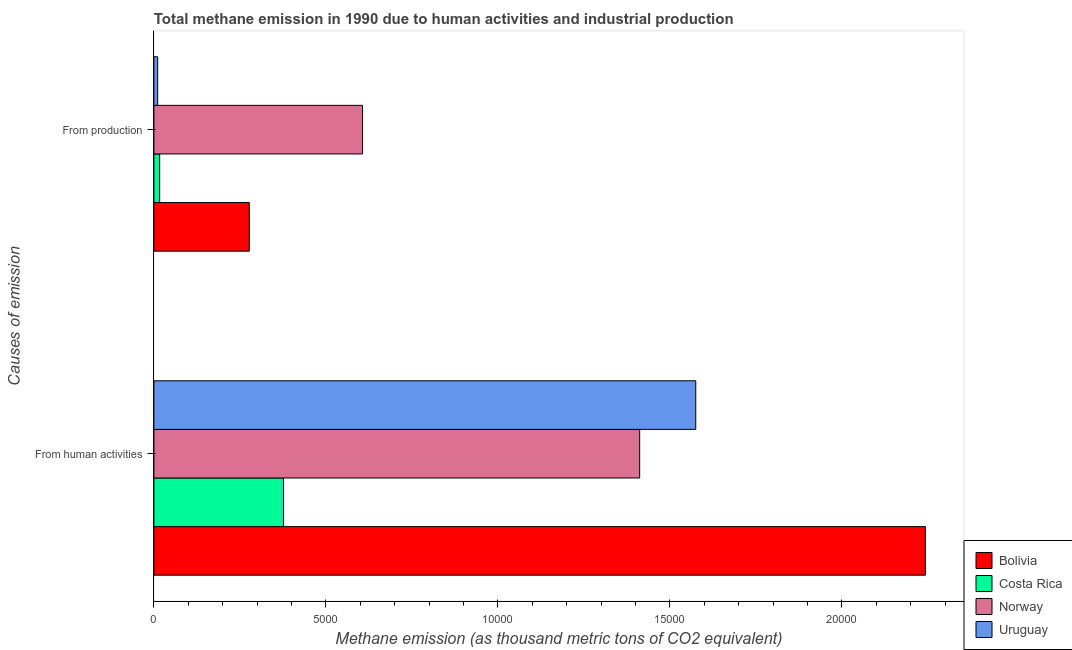How many groups of bars are there?
Your answer should be very brief. 2. How many bars are there on the 1st tick from the top?
Provide a short and direct response. 4. How many bars are there on the 1st tick from the bottom?
Your answer should be compact. 4. What is the label of the 2nd group of bars from the top?
Your answer should be compact. From human activities. What is the amount of emissions generated from industries in Bolivia?
Offer a very short reply. 2773.8. Across all countries, what is the maximum amount of emissions generated from industries?
Provide a short and direct response. 6065.9. Across all countries, what is the minimum amount of emissions from human activities?
Offer a terse response. 3768.5. In which country was the amount of emissions generated from industries maximum?
Offer a terse response. Norway. In which country was the amount of emissions from human activities minimum?
Ensure brevity in your answer.  Costa Rica. What is the total amount of emissions from human activities in the graph?
Your response must be concise. 5.61e+04. What is the difference between the amount of emissions generated from industries in Norway and that in Costa Rica?
Your response must be concise. 5897.7. What is the difference between the amount of emissions generated from industries in Uruguay and the amount of emissions from human activities in Costa Rica?
Your answer should be very brief. -3658.2. What is the average amount of emissions generated from industries per country?
Offer a terse response. 2279.55. What is the difference between the amount of emissions generated from industries and amount of emissions from human activities in Norway?
Offer a very short reply. -8056. In how many countries, is the amount of emissions from human activities greater than 6000 thousand metric tons?
Ensure brevity in your answer.  3. What is the ratio of the amount of emissions from human activities in Costa Rica to that in Norway?
Offer a terse response. 0.27. Is the amount of emissions generated from industries in Norway less than that in Bolivia?
Your answer should be very brief. No. What does the 1st bar from the top in From human activities represents?
Provide a short and direct response. Uruguay. What does the 1st bar from the bottom in From human activities represents?
Ensure brevity in your answer.  Bolivia. Does the graph contain any zero values?
Provide a short and direct response. No. How many legend labels are there?
Give a very brief answer. 4. What is the title of the graph?
Offer a terse response. Total methane emission in 1990 due to human activities and industrial production. Does "Macedonia" appear as one of the legend labels in the graph?
Give a very brief answer. No. What is the label or title of the X-axis?
Offer a very short reply. Methane emission (as thousand metric tons of CO2 equivalent). What is the label or title of the Y-axis?
Your answer should be compact. Causes of emission. What is the Methane emission (as thousand metric tons of CO2 equivalent) of Bolivia in From human activities?
Offer a very short reply. 2.24e+04. What is the Methane emission (as thousand metric tons of CO2 equivalent) in Costa Rica in From human activities?
Give a very brief answer. 3768.5. What is the Methane emission (as thousand metric tons of CO2 equivalent) in Norway in From human activities?
Your response must be concise. 1.41e+04. What is the Methane emission (as thousand metric tons of CO2 equivalent) in Uruguay in From human activities?
Your answer should be very brief. 1.58e+04. What is the Methane emission (as thousand metric tons of CO2 equivalent) of Bolivia in From production?
Your answer should be very brief. 2773.8. What is the Methane emission (as thousand metric tons of CO2 equivalent) in Costa Rica in From production?
Keep it short and to the point. 168.2. What is the Methane emission (as thousand metric tons of CO2 equivalent) of Norway in From production?
Provide a short and direct response. 6065.9. What is the Methane emission (as thousand metric tons of CO2 equivalent) of Uruguay in From production?
Offer a very short reply. 110.3. Across all Causes of emission, what is the maximum Methane emission (as thousand metric tons of CO2 equivalent) in Bolivia?
Give a very brief answer. 2.24e+04. Across all Causes of emission, what is the maximum Methane emission (as thousand metric tons of CO2 equivalent) in Costa Rica?
Give a very brief answer. 3768.5. Across all Causes of emission, what is the maximum Methane emission (as thousand metric tons of CO2 equivalent) in Norway?
Your answer should be compact. 1.41e+04. Across all Causes of emission, what is the maximum Methane emission (as thousand metric tons of CO2 equivalent) in Uruguay?
Ensure brevity in your answer.  1.58e+04. Across all Causes of emission, what is the minimum Methane emission (as thousand metric tons of CO2 equivalent) in Bolivia?
Offer a very short reply. 2773.8. Across all Causes of emission, what is the minimum Methane emission (as thousand metric tons of CO2 equivalent) in Costa Rica?
Offer a terse response. 168.2. Across all Causes of emission, what is the minimum Methane emission (as thousand metric tons of CO2 equivalent) in Norway?
Offer a very short reply. 6065.9. Across all Causes of emission, what is the minimum Methane emission (as thousand metric tons of CO2 equivalent) of Uruguay?
Offer a very short reply. 110.3. What is the total Methane emission (as thousand metric tons of CO2 equivalent) of Bolivia in the graph?
Your answer should be very brief. 2.52e+04. What is the total Methane emission (as thousand metric tons of CO2 equivalent) of Costa Rica in the graph?
Your answer should be compact. 3936.7. What is the total Methane emission (as thousand metric tons of CO2 equivalent) in Norway in the graph?
Your answer should be very brief. 2.02e+04. What is the total Methane emission (as thousand metric tons of CO2 equivalent) in Uruguay in the graph?
Your answer should be very brief. 1.59e+04. What is the difference between the Methane emission (as thousand metric tons of CO2 equivalent) of Bolivia in From human activities and that in From production?
Give a very brief answer. 1.97e+04. What is the difference between the Methane emission (as thousand metric tons of CO2 equivalent) in Costa Rica in From human activities and that in From production?
Give a very brief answer. 3600.3. What is the difference between the Methane emission (as thousand metric tons of CO2 equivalent) in Norway in From human activities and that in From production?
Make the answer very short. 8056. What is the difference between the Methane emission (as thousand metric tons of CO2 equivalent) of Uruguay in From human activities and that in From production?
Your response must be concise. 1.56e+04. What is the difference between the Methane emission (as thousand metric tons of CO2 equivalent) in Bolivia in From human activities and the Methane emission (as thousand metric tons of CO2 equivalent) in Costa Rica in From production?
Make the answer very short. 2.23e+04. What is the difference between the Methane emission (as thousand metric tons of CO2 equivalent) of Bolivia in From human activities and the Methane emission (as thousand metric tons of CO2 equivalent) of Norway in From production?
Your response must be concise. 1.64e+04. What is the difference between the Methane emission (as thousand metric tons of CO2 equivalent) in Bolivia in From human activities and the Methane emission (as thousand metric tons of CO2 equivalent) in Uruguay in From production?
Give a very brief answer. 2.23e+04. What is the difference between the Methane emission (as thousand metric tons of CO2 equivalent) in Costa Rica in From human activities and the Methane emission (as thousand metric tons of CO2 equivalent) in Norway in From production?
Provide a short and direct response. -2297.4. What is the difference between the Methane emission (as thousand metric tons of CO2 equivalent) of Costa Rica in From human activities and the Methane emission (as thousand metric tons of CO2 equivalent) of Uruguay in From production?
Ensure brevity in your answer.  3658.2. What is the difference between the Methane emission (as thousand metric tons of CO2 equivalent) in Norway in From human activities and the Methane emission (as thousand metric tons of CO2 equivalent) in Uruguay in From production?
Your answer should be compact. 1.40e+04. What is the average Methane emission (as thousand metric tons of CO2 equivalent) in Bolivia per Causes of emission?
Your answer should be compact. 1.26e+04. What is the average Methane emission (as thousand metric tons of CO2 equivalent) of Costa Rica per Causes of emission?
Provide a short and direct response. 1968.35. What is the average Methane emission (as thousand metric tons of CO2 equivalent) of Norway per Causes of emission?
Give a very brief answer. 1.01e+04. What is the average Methane emission (as thousand metric tons of CO2 equivalent) of Uruguay per Causes of emission?
Keep it short and to the point. 7931.2. What is the difference between the Methane emission (as thousand metric tons of CO2 equivalent) in Bolivia and Methane emission (as thousand metric tons of CO2 equivalent) in Costa Rica in From human activities?
Keep it short and to the point. 1.87e+04. What is the difference between the Methane emission (as thousand metric tons of CO2 equivalent) of Bolivia and Methane emission (as thousand metric tons of CO2 equivalent) of Norway in From human activities?
Provide a succinct answer. 8306.6. What is the difference between the Methane emission (as thousand metric tons of CO2 equivalent) in Bolivia and Methane emission (as thousand metric tons of CO2 equivalent) in Uruguay in From human activities?
Your answer should be very brief. 6676.4. What is the difference between the Methane emission (as thousand metric tons of CO2 equivalent) in Costa Rica and Methane emission (as thousand metric tons of CO2 equivalent) in Norway in From human activities?
Your response must be concise. -1.04e+04. What is the difference between the Methane emission (as thousand metric tons of CO2 equivalent) of Costa Rica and Methane emission (as thousand metric tons of CO2 equivalent) of Uruguay in From human activities?
Ensure brevity in your answer.  -1.20e+04. What is the difference between the Methane emission (as thousand metric tons of CO2 equivalent) of Norway and Methane emission (as thousand metric tons of CO2 equivalent) of Uruguay in From human activities?
Provide a short and direct response. -1630.2. What is the difference between the Methane emission (as thousand metric tons of CO2 equivalent) of Bolivia and Methane emission (as thousand metric tons of CO2 equivalent) of Costa Rica in From production?
Provide a succinct answer. 2605.6. What is the difference between the Methane emission (as thousand metric tons of CO2 equivalent) of Bolivia and Methane emission (as thousand metric tons of CO2 equivalent) of Norway in From production?
Ensure brevity in your answer.  -3292.1. What is the difference between the Methane emission (as thousand metric tons of CO2 equivalent) in Bolivia and Methane emission (as thousand metric tons of CO2 equivalent) in Uruguay in From production?
Offer a very short reply. 2663.5. What is the difference between the Methane emission (as thousand metric tons of CO2 equivalent) in Costa Rica and Methane emission (as thousand metric tons of CO2 equivalent) in Norway in From production?
Your answer should be very brief. -5897.7. What is the difference between the Methane emission (as thousand metric tons of CO2 equivalent) of Costa Rica and Methane emission (as thousand metric tons of CO2 equivalent) of Uruguay in From production?
Your answer should be compact. 57.9. What is the difference between the Methane emission (as thousand metric tons of CO2 equivalent) of Norway and Methane emission (as thousand metric tons of CO2 equivalent) of Uruguay in From production?
Ensure brevity in your answer.  5955.6. What is the ratio of the Methane emission (as thousand metric tons of CO2 equivalent) in Bolivia in From human activities to that in From production?
Your response must be concise. 8.09. What is the ratio of the Methane emission (as thousand metric tons of CO2 equivalent) of Costa Rica in From human activities to that in From production?
Offer a very short reply. 22.4. What is the ratio of the Methane emission (as thousand metric tons of CO2 equivalent) in Norway in From human activities to that in From production?
Offer a terse response. 2.33. What is the ratio of the Methane emission (as thousand metric tons of CO2 equivalent) in Uruguay in From human activities to that in From production?
Ensure brevity in your answer.  142.81. What is the difference between the highest and the second highest Methane emission (as thousand metric tons of CO2 equivalent) of Bolivia?
Make the answer very short. 1.97e+04. What is the difference between the highest and the second highest Methane emission (as thousand metric tons of CO2 equivalent) in Costa Rica?
Your answer should be very brief. 3600.3. What is the difference between the highest and the second highest Methane emission (as thousand metric tons of CO2 equivalent) in Norway?
Provide a short and direct response. 8056. What is the difference between the highest and the second highest Methane emission (as thousand metric tons of CO2 equivalent) in Uruguay?
Your answer should be compact. 1.56e+04. What is the difference between the highest and the lowest Methane emission (as thousand metric tons of CO2 equivalent) in Bolivia?
Offer a very short reply. 1.97e+04. What is the difference between the highest and the lowest Methane emission (as thousand metric tons of CO2 equivalent) of Costa Rica?
Your response must be concise. 3600.3. What is the difference between the highest and the lowest Methane emission (as thousand metric tons of CO2 equivalent) in Norway?
Your response must be concise. 8056. What is the difference between the highest and the lowest Methane emission (as thousand metric tons of CO2 equivalent) of Uruguay?
Your answer should be compact. 1.56e+04. 